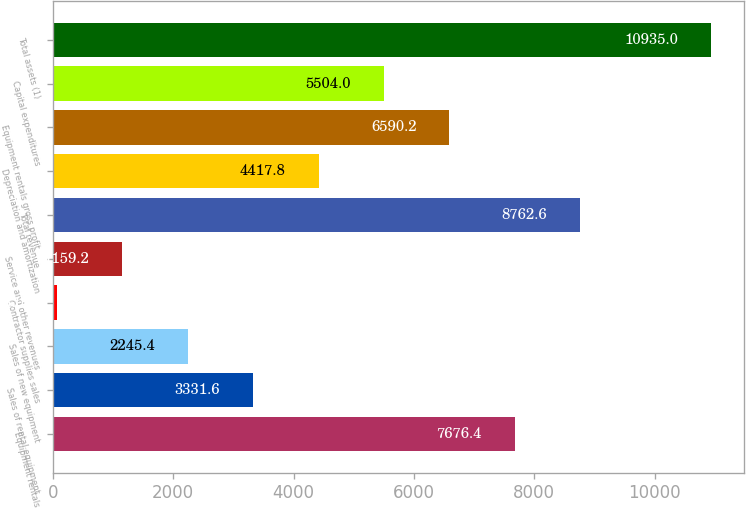<chart> <loc_0><loc_0><loc_500><loc_500><bar_chart><fcel>Equipment rentals<fcel>Sales of rental equipment<fcel>Sales of new equipment<fcel>Contractor supplies sales<fcel>Service and other revenues<fcel>Total revenue<fcel>Depreciation and amortization<fcel>Equipment rentals gross profit<fcel>Capital expenditures<fcel>Total assets (1)<nl><fcel>7676.4<fcel>3331.6<fcel>2245.4<fcel>73<fcel>1159.2<fcel>8762.6<fcel>4417.8<fcel>6590.2<fcel>5504<fcel>10935<nl></chart> 